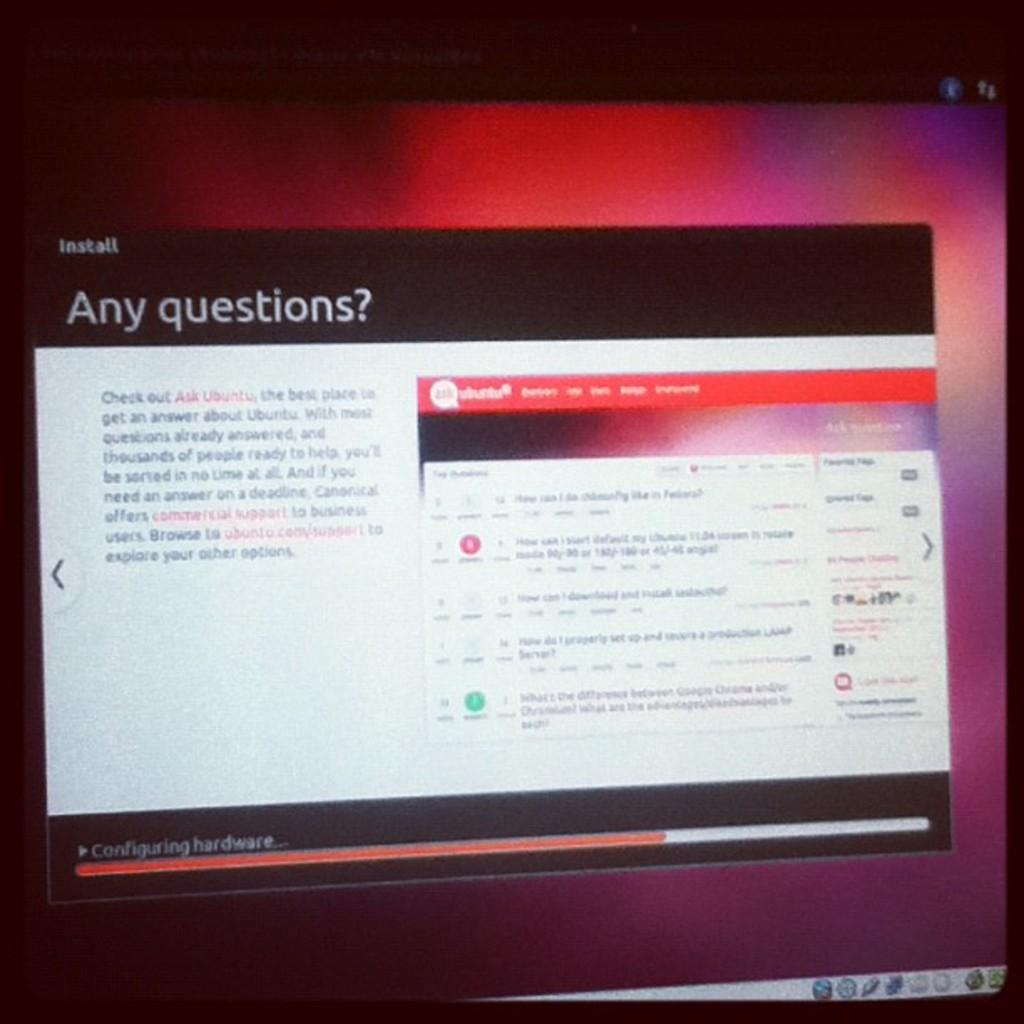What question is at the top of the page?
Your answer should be very brief. Any questions?. 